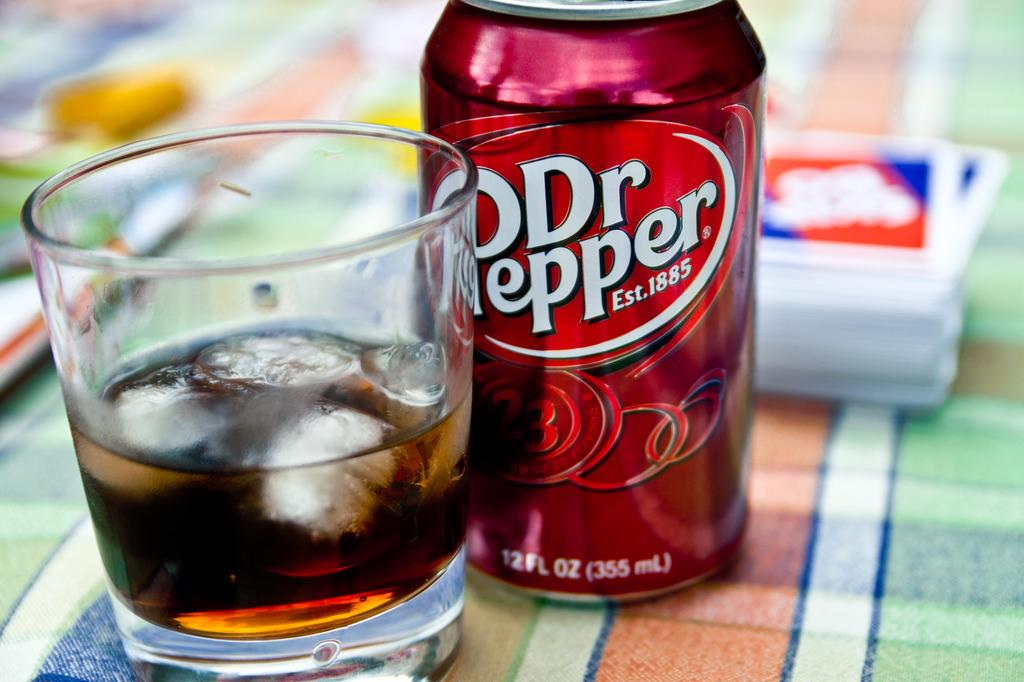<image>
Give a short and clear explanation of the subsequent image. A glass with ice in it sitting next to a can of Dr. Pepper that was established in 1885. 